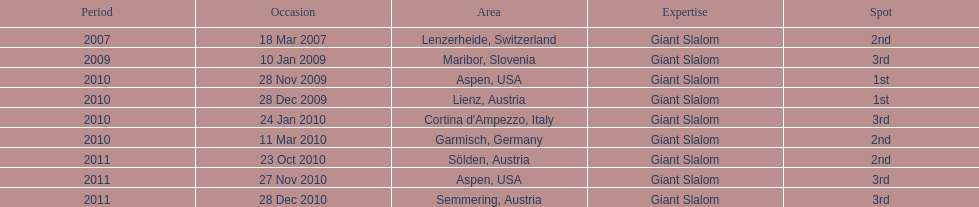Aspen and lienz in 2009 are the only races where this racer got what position? 1st. 